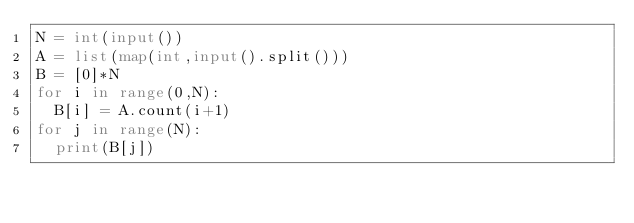Convert code to text. <code><loc_0><loc_0><loc_500><loc_500><_Python_>N = int(input())
A = list(map(int,input().split()))
B = [0]*N
for i in range(0,N):
  B[i] = A.count(i+1)
for j in range(N):
  print(B[j])</code> 